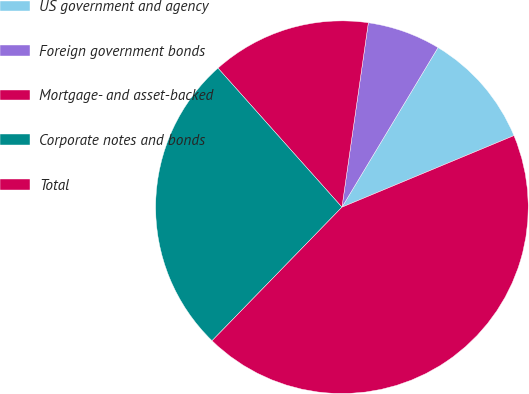Convert chart. <chart><loc_0><loc_0><loc_500><loc_500><pie_chart><fcel>US government and agency<fcel>Foreign government bonds<fcel>Mortgage- and asset-backed<fcel>Corporate notes and bonds<fcel>Total<nl><fcel>10.1%<fcel>6.36%<fcel>13.85%<fcel>26.13%<fcel>43.55%<nl></chart> 